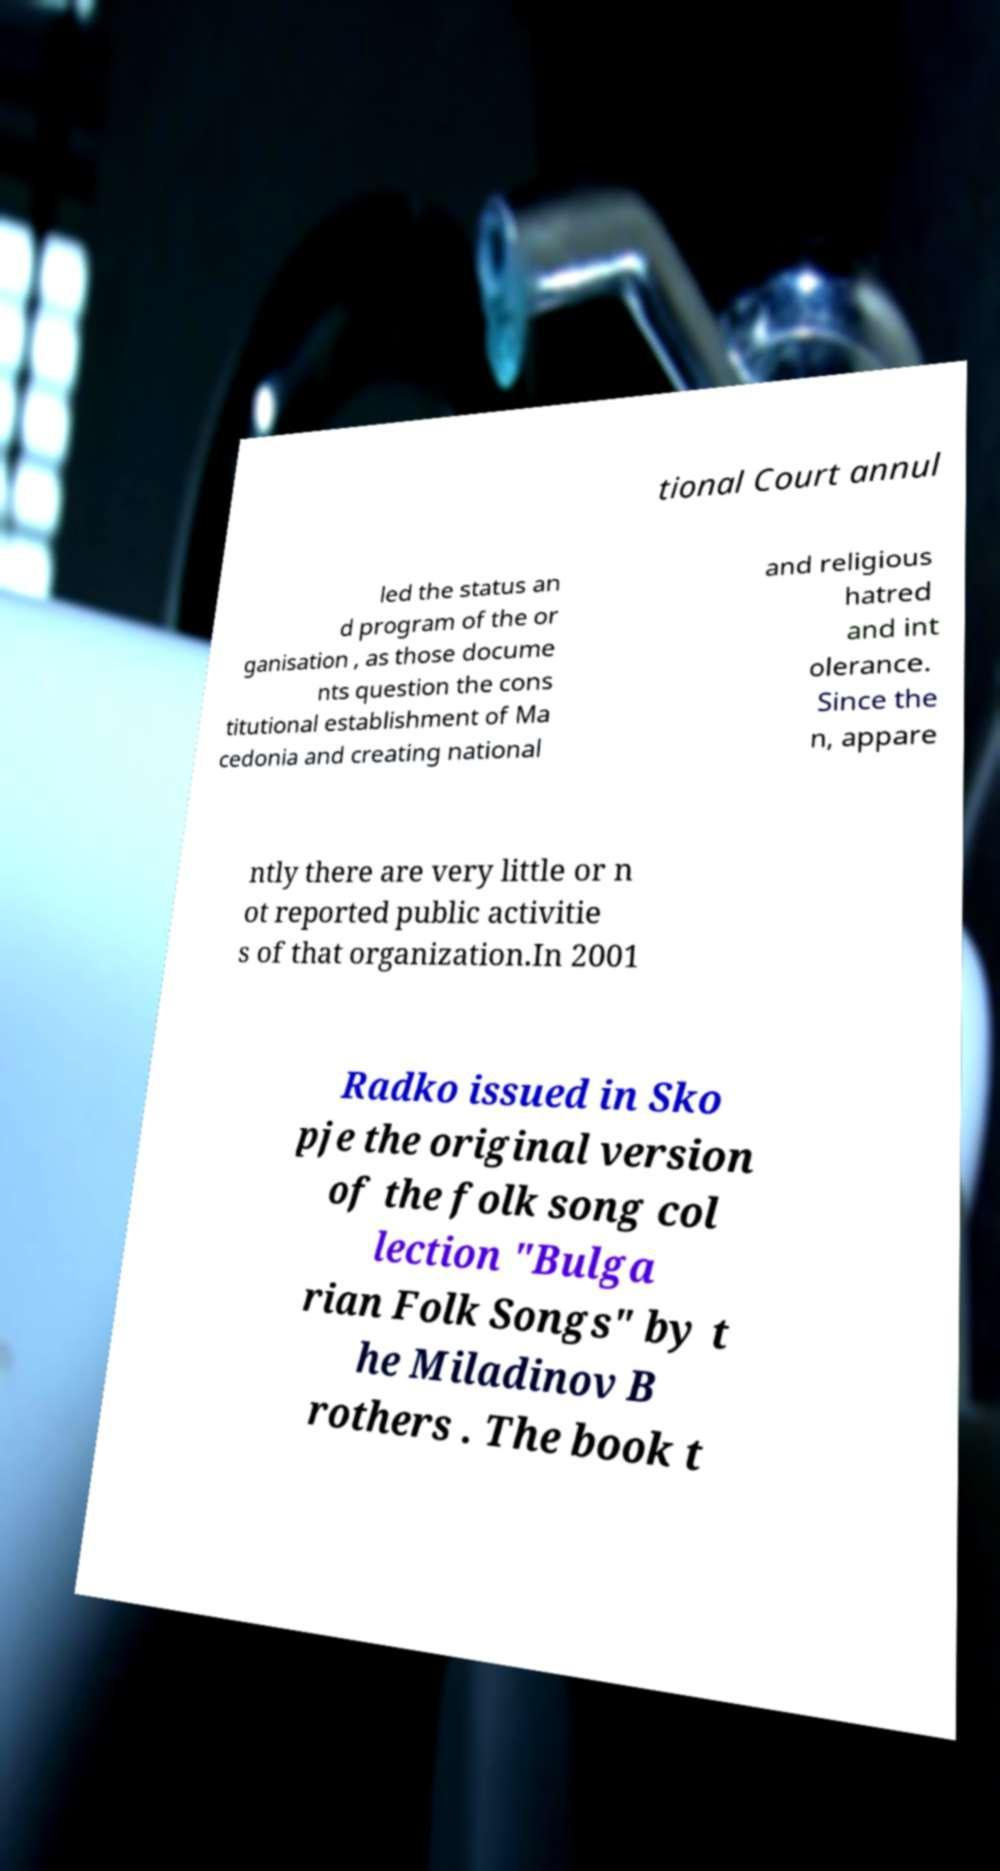For documentation purposes, I need the text within this image transcribed. Could you provide that? tional Court annul led the status an d program of the or ganisation , as those docume nts question the cons titutional establishment of Ma cedonia and creating national and religious hatred and int olerance. Since the n, appare ntly there are very little or n ot reported public activitie s of that organization.In 2001 Radko issued in Sko pje the original version of the folk song col lection "Bulga rian Folk Songs" by t he Miladinov B rothers . The book t 